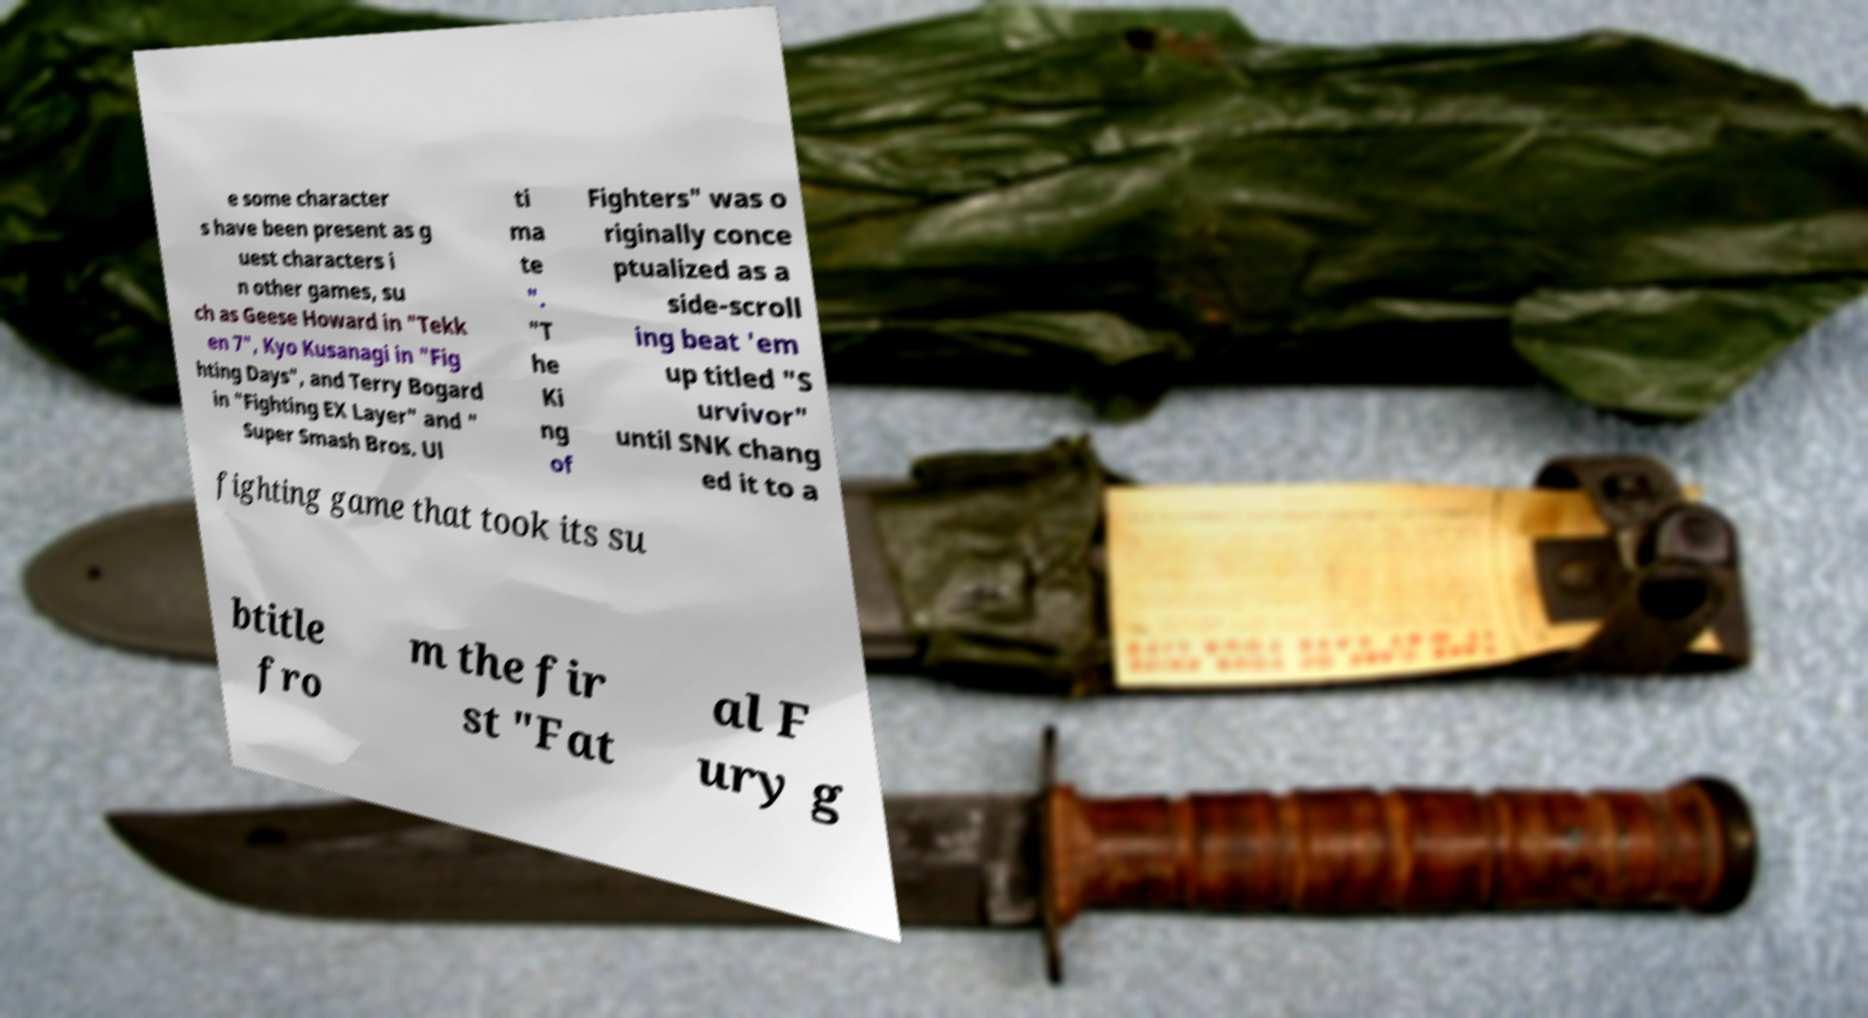Can you read and provide the text displayed in the image?This photo seems to have some interesting text. Can you extract and type it out for me? e some character s have been present as g uest characters i n other games, su ch as Geese Howard in "Tekk en 7", Kyo Kusanagi in "Fig hting Days", and Terry Bogard in "Fighting EX Layer" and " Super Smash Bros. Ul ti ma te ". "T he Ki ng of Fighters" was o riginally conce ptualized as a side-scroll ing beat 'em up titled "S urvivor" until SNK chang ed it to a fighting game that took its su btitle fro m the fir st "Fat al F ury g 